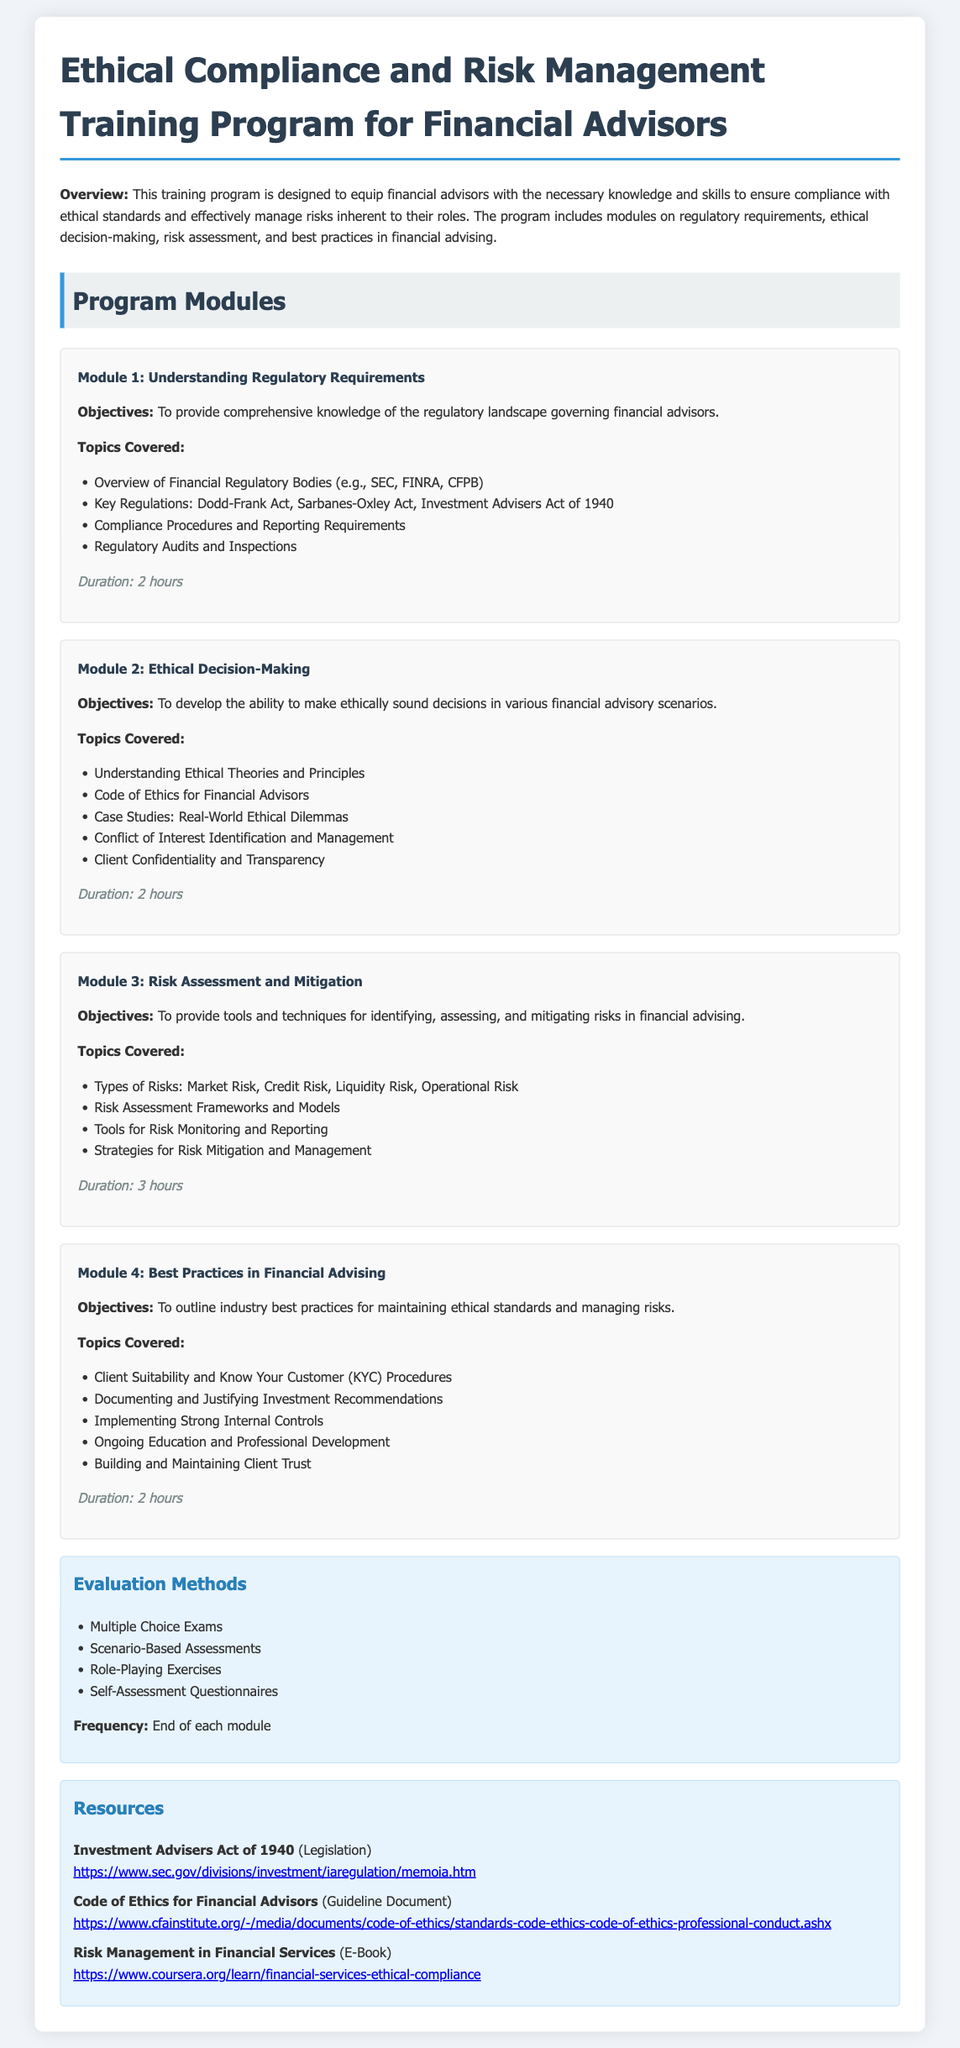What is the duration of Module 1? The duration is explicitly mentioned in the module details under "Duration".
Answer: 2 hours What is the objective of Module 2? The objectives are stated at the beginning of each module.
Answer: To develop the ability to make ethically sound decisions in various financial advisory scenarios Which regulation is highlighted under Module 1? The specific regulations are listed in "Key Regulations" under the module topics.
Answer: Dodd-Frank Act How many evaluation methods are listed in the document? The number of evaluation methods is counted from the list under "Evaluation Methods".
Answer: Four What type of risk is addressed in Module 3? The types of risks are outlined in the "Types of Risks" section of Module 3.
Answer: Market Risk What is one of the resources provided in the syllabus? Resources are listed under the "Resources" section, with specific documents highlighted.
Answer: Investment Advisers Act of 1940 What is the title of the training program? The title is specified at the top of the document.
Answer: Ethical Compliance and Risk Management Training Program for Financial Advisors What is the main focus of Module 4? The focus of each module is provided in the objectives section, indicating what best practices will be outlined.
Answer: To outline industry best practices for maintaining ethical standards and managing risks 